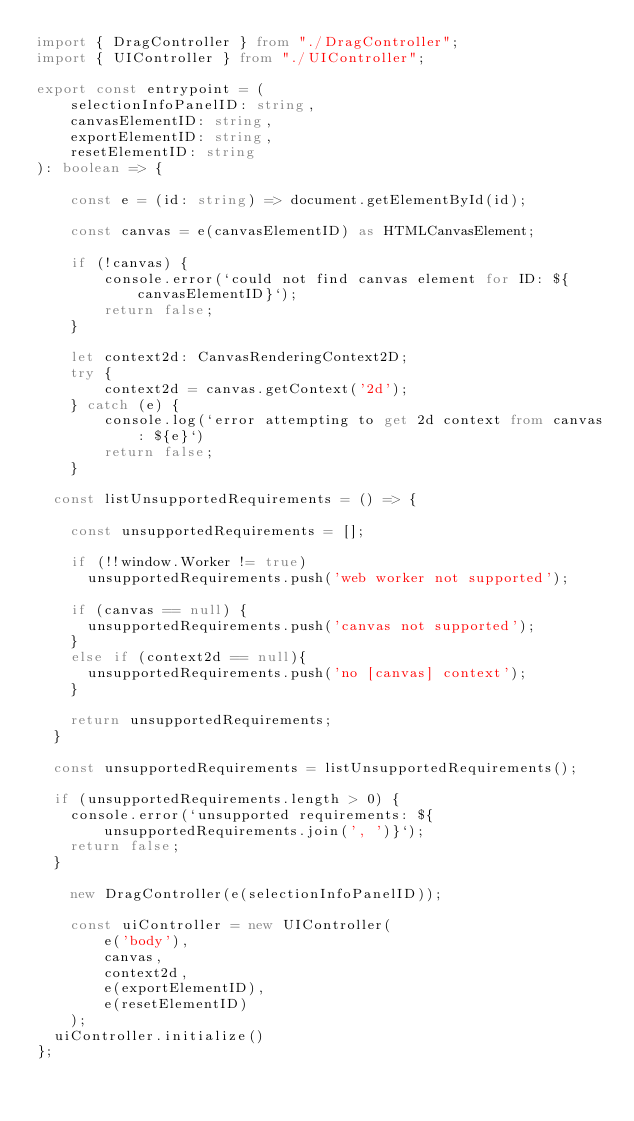Convert code to text. <code><loc_0><loc_0><loc_500><loc_500><_TypeScript_>import { DragController } from "./DragController";
import { UIController } from "./UIController";

export const entrypoint = (
    selectionInfoPanelID: string,
    canvasElementID: string,
    exportElementID: string,
    resetElementID: string
): boolean => {		
    
    const e = (id: string) => document.getElementById(id);

    const canvas = e(canvasElementID) as HTMLCanvasElement;
    
    if (!canvas) {
        console.error(`could not find canvas element for ID: ${canvasElementID}`);
        return false;
    }
    
    let context2d: CanvasRenderingContext2D;
    try {
        context2d = canvas.getContext('2d');
    } catch (e) {
        console.log(`error attempting to get 2d context from canvas: ${e}`)
        return false;
    }

	const listUnsupportedRequirements = () => {
	
		const unsupportedRequirements = []; 
		
		if (!!window.Worker != true)
			unsupportedRequirements.push('web worker not supported');
			
		if (canvas == null) {
			unsupportedRequirements.push('canvas not supported');
		}
		else if (context2d == null){ 	
			unsupportedRequirements.push('no [canvas] context');
		}				
		
		return unsupportedRequirements;
	}					
	
	const unsupportedRequirements = listUnsupportedRequirements();				
	if (unsupportedRequirements.length > 0) {
		console.error(`unsupported requirements: ${unsupportedRequirements.join(', ')}`);
		return false;
	}

    new DragController(e(selectionInfoPanelID));
    
    const uiController = new UIController(
        e('body'), 
        canvas, 
        context2d, 
        e(exportElementID), 
        e(resetElementID)
    );
	uiController.initialize()
};</code> 